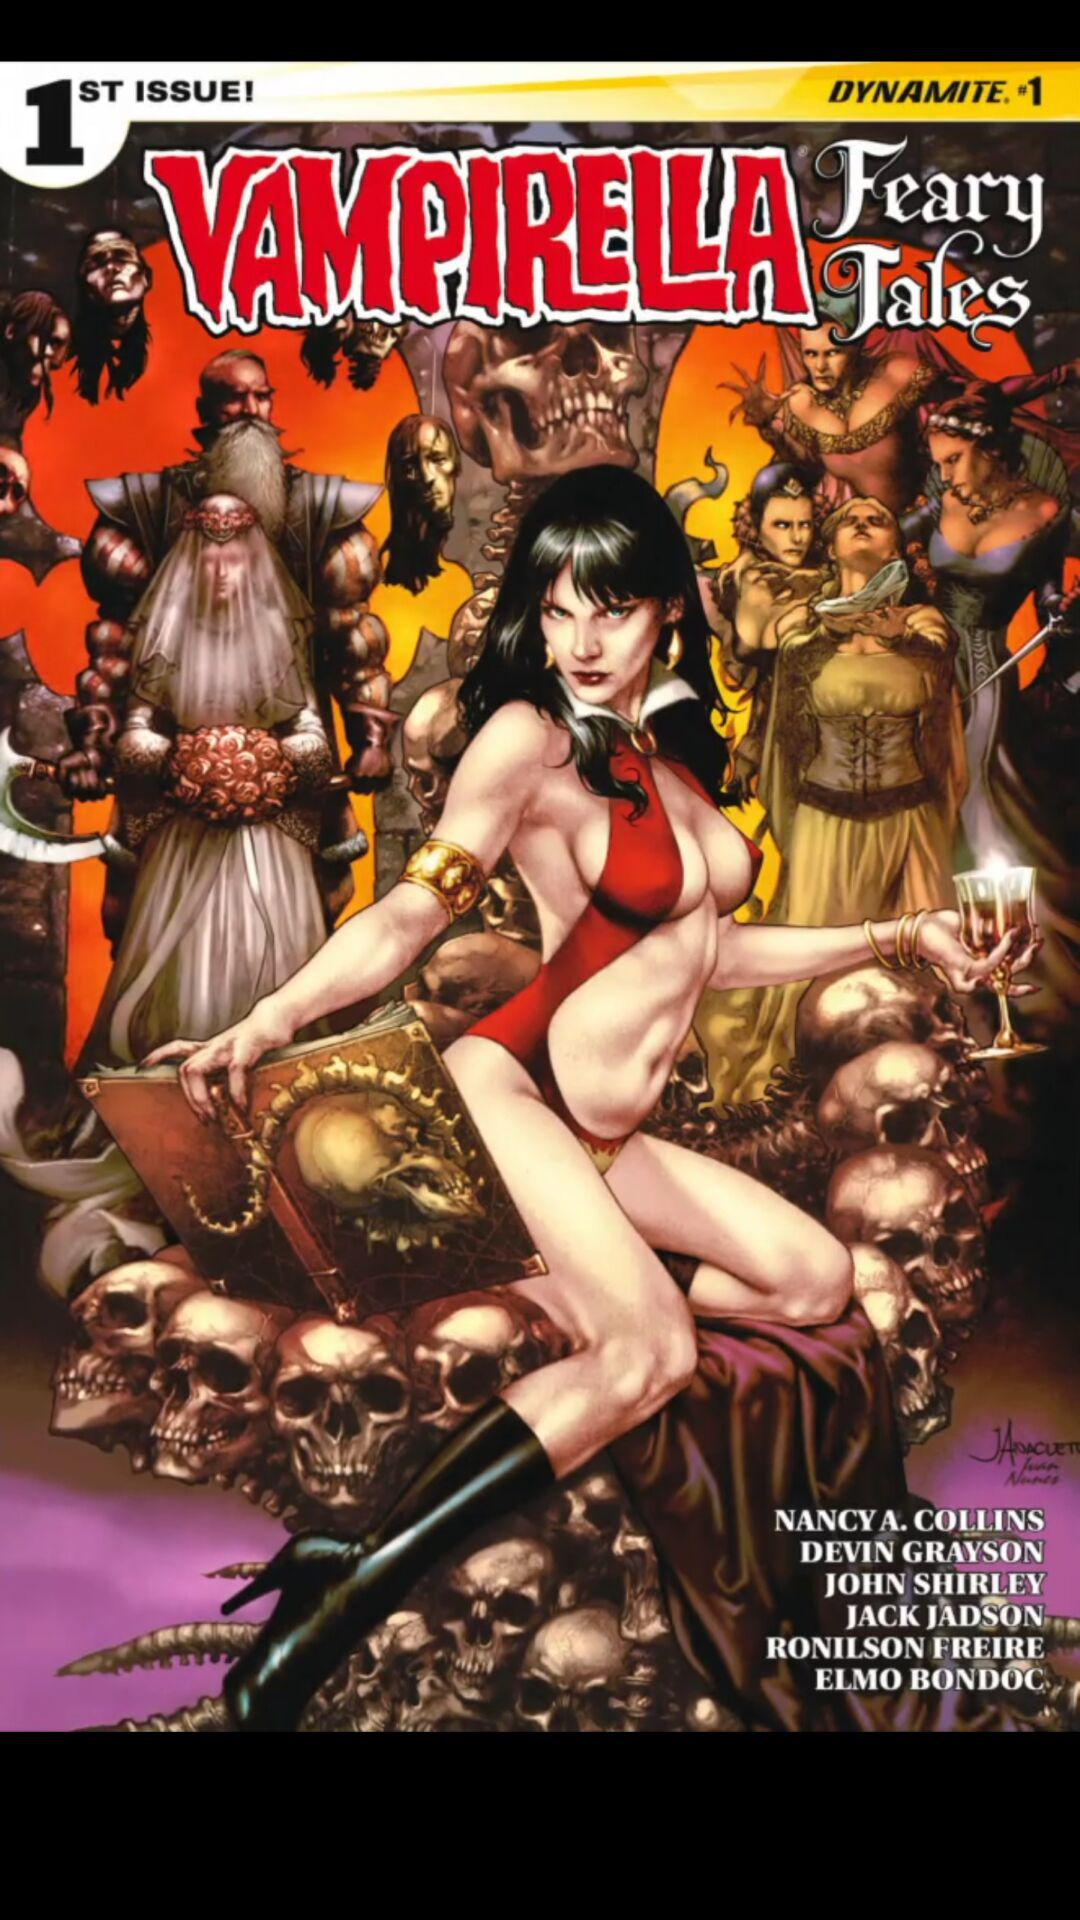How much does the comic cost?
When the provided information is insufficient, respond with <no answer>. <no answer> 